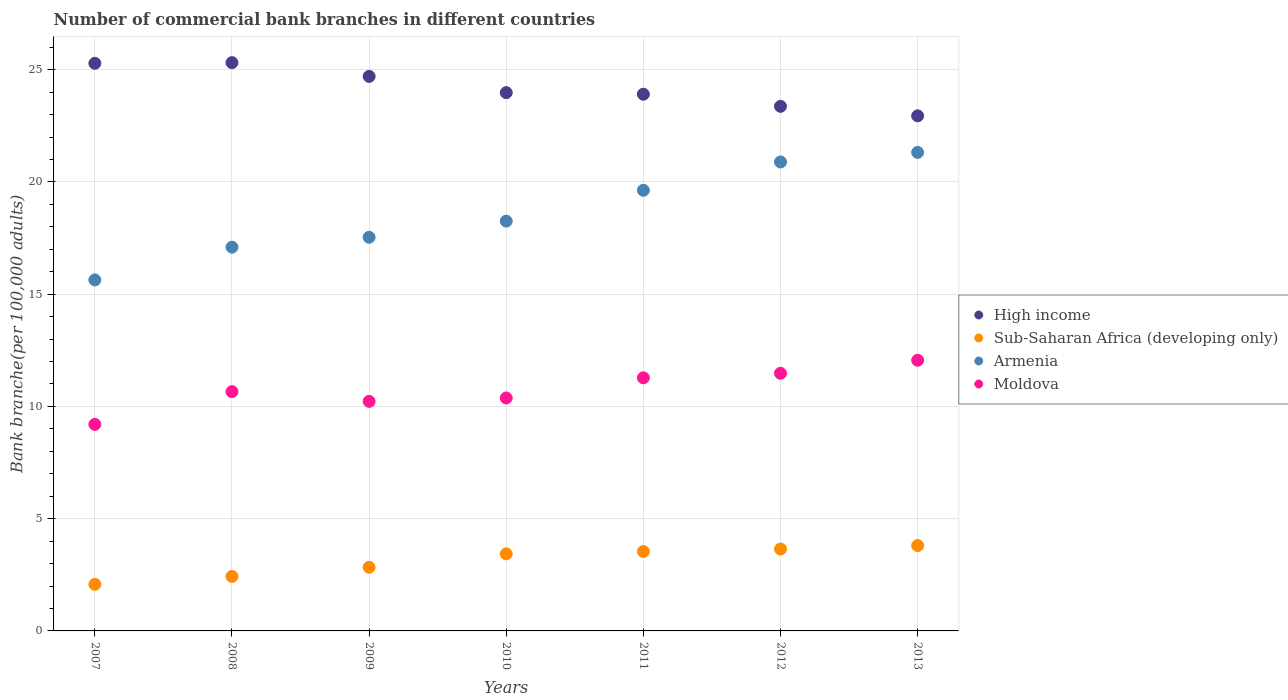How many different coloured dotlines are there?
Make the answer very short. 4. What is the number of commercial bank branches in Sub-Saharan Africa (developing only) in 2010?
Your answer should be compact. 3.43. Across all years, what is the maximum number of commercial bank branches in Moldova?
Keep it short and to the point. 12.06. Across all years, what is the minimum number of commercial bank branches in Sub-Saharan Africa (developing only)?
Your response must be concise. 2.07. In which year was the number of commercial bank branches in Sub-Saharan Africa (developing only) maximum?
Give a very brief answer. 2013. In which year was the number of commercial bank branches in Armenia minimum?
Your answer should be very brief. 2007. What is the total number of commercial bank branches in Armenia in the graph?
Your response must be concise. 130.35. What is the difference between the number of commercial bank branches in Sub-Saharan Africa (developing only) in 2009 and that in 2012?
Your answer should be very brief. -0.81. What is the difference between the number of commercial bank branches in Moldova in 2009 and the number of commercial bank branches in High income in 2008?
Your response must be concise. -15.09. What is the average number of commercial bank branches in Armenia per year?
Your answer should be very brief. 18.62. In the year 2010, what is the difference between the number of commercial bank branches in High income and number of commercial bank branches in Sub-Saharan Africa (developing only)?
Offer a terse response. 20.54. In how many years, is the number of commercial bank branches in High income greater than 4?
Your answer should be compact. 7. What is the ratio of the number of commercial bank branches in Moldova in 2009 to that in 2013?
Provide a short and direct response. 0.85. Is the difference between the number of commercial bank branches in High income in 2009 and 2013 greater than the difference between the number of commercial bank branches in Sub-Saharan Africa (developing only) in 2009 and 2013?
Your response must be concise. Yes. What is the difference between the highest and the second highest number of commercial bank branches in Armenia?
Your answer should be very brief. 0.43. What is the difference between the highest and the lowest number of commercial bank branches in Armenia?
Offer a terse response. 5.68. Is the sum of the number of commercial bank branches in High income in 2008 and 2012 greater than the maximum number of commercial bank branches in Sub-Saharan Africa (developing only) across all years?
Your answer should be compact. Yes. Is it the case that in every year, the sum of the number of commercial bank branches in High income and number of commercial bank branches in Armenia  is greater than the sum of number of commercial bank branches in Sub-Saharan Africa (developing only) and number of commercial bank branches in Moldova?
Give a very brief answer. Yes. Does the number of commercial bank branches in High income monotonically increase over the years?
Your response must be concise. No. Is the number of commercial bank branches in Moldova strictly greater than the number of commercial bank branches in Sub-Saharan Africa (developing only) over the years?
Ensure brevity in your answer.  Yes. Is the number of commercial bank branches in Armenia strictly less than the number of commercial bank branches in High income over the years?
Keep it short and to the point. Yes. What is the difference between two consecutive major ticks on the Y-axis?
Keep it short and to the point. 5. Are the values on the major ticks of Y-axis written in scientific E-notation?
Provide a short and direct response. No. Does the graph contain any zero values?
Your response must be concise. No. How are the legend labels stacked?
Keep it short and to the point. Vertical. What is the title of the graph?
Give a very brief answer. Number of commercial bank branches in different countries. What is the label or title of the X-axis?
Your answer should be compact. Years. What is the label or title of the Y-axis?
Provide a short and direct response. Bank branche(per 100,0 adults). What is the Bank branche(per 100,000 adults) of High income in 2007?
Your answer should be very brief. 25.28. What is the Bank branche(per 100,000 adults) in Sub-Saharan Africa (developing only) in 2007?
Your response must be concise. 2.07. What is the Bank branche(per 100,000 adults) of Armenia in 2007?
Your answer should be very brief. 15.63. What is the Bank branche(per 100,000 adults) in Moldova in 2007?
Your response must be concise. 9.2. What is the Bank branche(per 100,000 adults) in High income in 2008?
Your answer should be compact. 25.31. What is the Bank branche(per 100,000 adults) in Sub-Saharan Africa (developing only) in 2008?
Give a very brief answer. 2.43. What is the Bank branche(per 100,000 adults) of Armenia in 2008?
Your answer should be very brief. 17.09. What is the Bank branche(per 100,000 adults) of Moldova in 2008?
Provide a succinct answer. 10.66. What is the Bank branche(per 100,000 adults) of High income in 2009?
Provide a succinct answer. 24.7. What is the Bank branche(per 100,000 adults) in Sub-Saharan Africa (developing only) in 2009?
Provide a succinct answer. 2.83. What is the Bank branche(per 100,000 adults) of Armenia in 2009?
Ensure brevity in your answer.  17.53. What is the Bank branche(per 100,000 adults) of Moldova in 2009?
Keep it short and to the point. 10.23. What is the Bank branche(per 100,000 adults) in High income in 2010?
Provide a succinct answer. 23.98. What is the Bank branche(per 100,000 adults) in Sub-Saharan Africa (developing only) in 2010?
Provide a short and direct response. 3.43. What is the Bank branche(per 100,000 adults) in Armenia in 2010?
Keep it short and to the point. 18.25. What is the Bank branche(per 100,000 adults) in Moldova in 2010?
Offer a terse response. 10.38. What is the Bank branche(per 100,000 adults) in High income in 2011?
Your answer should be compact. 23.91. What is the Bank branche(per 100,000 adults) in Sub-Saharan Africa (developing only) in 2011?
Provide a succinct answer. 3.54. What is the Bank branche(per 100,000 adults) of Armenia in 2011?
Your response must be concise. 19.63. What is the Bank branche(per 100,000 adults) of Moldova in 2011?
Give a very brief answer. 11.28. What is the Bank branche(per 100,000 adults) of High income in 2012?
Offer a terse response. 23.37. What is the Bank branche(per 100,000 adults) of Sub-Saharan Africa (developing only) in 2012?
Ensure brevity in your answer.  3.65. What is the Bank branche(per 100,000 adults) in Armenia in 2012?
Provide a short and direct response. 20.89. What is the Bank branche(per 100,000 adults) in Moldova in 2012?
Keep it short and to the point. 11.48. What is the Bank branche(per 100,000 adults) of High income in 2013?
Your answer should be very brief. 22.94. What is the Bank branche(per 100,000 adults) in Sub-Saharan Africa (developing only) in 2013?
Offer a terse response. 3.8. What is the Bank branche(per 100,000 adults) in Armenia in 2013?
Keep it short and to the point. 21.32. What is the Bank branche(per 100,000 adults) of Moldova in 2013?
Your answer should be compact. 12.06. Across all years, what is the maximum Bank branche(per 100,000 adults) in High income?
Provide a short and direct response. 25.31. Across all years, what is the maximum Bank branche(per 100,000 adults) of Sub-Saharan Africa (developing only)?
Keep it short and to the point. 3.8. Across all years, what is the maximum Bank branche(per 100,000 adults) in Armenia?
Provide a short and direct response. 21.32. Across all years, what is the maximum Bank branche(per 100,000 adults) in Moldova?
Your response must be concise. 12.06. Across all years, what is the minimum Bank branche(per 100,000 adults) in High income?
Provide a succinct answer. 22.94. Across all years, what is the minimum Bank branche(per 100,000 adults) in Sub-Saharan Africa (developing only)?
Keep it short and to the point. 2.07. Across all years, what is the minimum Bank branche(per 100,000 adults) in Armenia?
Keep it short and to the point. 15.63. Across all years, what is the minimum Bank branche(per 100,000 adults) in Moldova?
Your response must be concise. 9.2. What is the total Bank branche(per 100,000 adults) in High income in the graph?
Provide a short and direct response. 169.49. What is the total Bank branche(per 100,000 adults) in Sub-Saharan Africa (developing only) in the graph?
Your response must be concise. 21.75. What is the total Bank branche(per 100,000 adults) in Armenia in the graph?
Your response must be concise. 130.35. What is the total Bank branche(per 100,000 adults) in Moldova in the graph?
Give a very brief answer. 75.27. What is the difference between the Bank branche(per 100,000 adults) in High income in 2007 and that in 2008?
Your response must be concise. -0.03. What is the difference between the Bank branche(per 100,000 adults) of Sub-Saharan Africa (developing only) in 2007 and that in 2008?
Your answer should be very brief. -0.35. What is the difference between the Bank branche(per 100,000 adults) of Armenia in 2007 and that in 2008?
Your answer should be very brief. -1.46. What is the difference between the Bank branche(per 100,000 adults) in Moldova in 2007 and that in 2008?
Make the answer very short. -1.46. What is the difference between the Bank branche(per 100,000 adults) of High income in 2007 and that in 2009?
Keep it short and to the point. 0.58. What is the difference between the Bank branche(per 100,000 adults) of Sub-Saharan Africa (developing only) in 2007 and that in 2009?
Ensure brevity in your answer.  -0.76. What is the difference between the Bank branche(per 100,000 adults) in Moldova in 2007 and that in 2009?
Provide a succinct answer. -1.02. What is the difference between the Bank branche(per 100,000 adults) in High income in 2007 and that in 2010?
Give a very brief answer. 1.31. What is the difference between the Bank branche(per 100,000 adults) in Sub-Saharan Africa (developing only) in 2007 and that in 2010?
Your answer should be very brief. -1.36. What is the difference between the Bank branche(per 100,000 adults) of Armenia in 2007 and that in 2010?
Your answer should be compact. -2.62. What is the difference between the Bank branche(per 100,000 adults) of Moldova in 2007 and that in 2010?
Offer a terse response. -1.18. What is the difference between the Bank branche(per 100,000 adults) in High income in 2007 and that in 2011?
Your answer should be very brief. 1.38. What is the difference between the Bank branche(per 100,000 adults) of Sub-Saharan Africa (developing only) in 2007 and that in 2011?
Offer a very short reply. -1.46. What is the difference between the Bank branche(per 100,000 adults) of Armenia in 2007 and that in 2011?
Offer a very short reply. -3.99. What is the difference between the Bank branche(per 100,000 adults) in Moldova in 2007 and that in 2011?
Offer a very short reply. -2.07. What is the difference between the Bank branche(per 100,000 adults) of High income in 2007 and that in 2012?
Your answer should be compact. 1.92. What is the difference between the Bank branche(per 100,000 adults) of Sub-Saharan Africa (developing only) in 2007 and that in 2012?
Provide a succinct answer. -1.57. What is the difference between the Bank branche(per 100,000 adults) of Armenia in 2007 and that in 2012?
Your answer should be very brief. -5.25. What is the difference between the Bank branche(per 100,000 adults) of Moldova in 2007 and that in 2012?
Keep it short and to the point. -2.27. What is the difference between the Bank branche(per 100,000 adults) in High income in 2007 and that in 2013?
Make the answer very short. 2.34. What is the difference between the Bank branche(per 100,000 adults) of Sub-Saharan Africa (developing only) in 2007 and that in 2013?
Keep it short and to the point. -1.73. What is the difference between the Bank branche(per 100,000 adults) in Armenia in 2007 and that in 2013?
Your answer should be compact. -5.68. What is the difference between the Bank branche(per 100,000 adults) in Moldova in 2007 and that in 2013?
Ensure brevity in your answer.  -2.86. What is the difference between the Bank branche(per 100,000 adults) in High income in 2008 and that in 2009?
Offer a very short reply. 0.61. What is the difference between the Bank branche(per 100,000 adults) in Sub-Saharan Africa (developing only) in 2008 and that in 2009?
Provide a short and direct response. -0.41. What is the difference between the Bank branche(per 100,000 adults) in Armenia in 2008 and that in 2009?
Offer a very short reply. -0.44. What is the difference between the Bank branche(per 100,000 adults) of Moldova in 2008 and that in 2009?
Provide a short and direct response. 0.43. What is the difference between the Bank branche(per 100,000 adults) in High income in 2008 and that in 2010?
Your answer should be compact. 1.34. What is the difference between the Bank branche(per 100,000 adults) in Sub-Saharan Africa (developing only) in 2008 and that in 2010?
Offer a very short reply. -1. What is the difference between the Bank branche(per 100,000 adults) of Armenia in 2008 and that in 2010?
Make the answer very short. -1.16. What is the difference between the Bank branche(per 100,000 adults) in Moldova in 2008 and that in 2010?
Your response must be concise. 0.28. What is the difference between the Bank branche(per 100,000 adults) of High income in 2008 and that in 2011?
Provide a short and direct response. 1.41. What is the difference between the Bank branche(per 100,000 adults) in Sub-Saharan Africa (developing only) in 2008 and that in 2011?
Offer a very short reply. -1.11. What is the difference between the Bank branche(per 100,000 adults) in Armenia in 2008 and that in 2011?
Give a very brief answer. -2.53. What is the difference between the Bank branche(per 100,000 adults) of Moldova in 2008 and that in 2011?
Your answer should be compact. -0.62. What is the difference between the Bank branche(per 100,000 adults) of High income in 2008 and that in 2012?
Your answer should be compact. 1.95. What is the difference between the Bank branche(per 100,000 adults) in Sub-Saharan Africa (developing only) in 2008 and that in 2012?
Your answer should be compact. -1.22. What is the difference between the Bank branche(per 100,000 adults) in Armenia in 2008 and that in 2012?
Your answer should be very brief. -3.79. What is the difference between the Bank branche(per 100,000 adults) in Moldova in 2008 and that in 2012?
Ensure brevity in your answer.  -0.82. What is the difference between the Bank branche(per 100,000 adults) in High income in 2008 and that in 2013?
Your response must be concise. 2.37. What is the difference between the Bank branche(per 100,000 adults) in Sub-Saharan Africa (developing only) in 2008 and that in 2013?
Ensure brevity in your answer.  -1.37. What is the difference between the Bank branche(per 100,000 adults) of Armenia in 2008 and that in 2013?
Provide a succinct answer. -4.22. What is the difference between the Bank branche(per 100,000 adults) in Moldova in 2008 and that in 2013?
Keep it short and to the point. -1.4. What is the difference between the Bank branche(per 100,000 adults) of High income in 2009 and that in 2010?
Offer a very short reply. 0.72. What is the difference between the Bank branche(per 100,000 adults) of Sub-Saharan Africa (developing only) in 2009 and that in 2010?
Your answer should be very brief. -0.6. What is the difference between the Bank branche(per 100,000 adults) of Armenia in 2009 and that in 2010?
Provide a succinct answer. -0.72. What is the difference between the Bank branche(per 100,000 adults) in Moldova in 2009 and that in 2010?
Your answer should be compact. -0.15. What is the difference between the Bank branche(per 100,000 adults) of High income in 2009 and that in 2011?
Your response must be concise. 0.79. What is the difference between the Bank branche(per 100,000 adults) of Sub-Saharan Africa (developing only) in 2009 and that in 2011?
Offer a terse response. -0.7. What is the difference between the Bank branche(per 100,000 adults) of Armenia in 2009 and that in 2011?
Keep it short and to the point. -2.09. What is the difference between the Bank branche(per 100,000 adults) in Moldova in 2009 and that in 2011?
Provide a succinct answer. -1.05. What is the difference between the Bank branche(per 100,000 adults) of High income in 2009 and that in 2012?
Your answer should be compact. 1.33. What is the difference between the Bank branche(per 100,000 adults) in Sub-Saharan Africa (developing only) in 2009 and that in 2012?
Keep it short and to the point. -0.81. What is the difference between the Bank branche(per 100,000 adults) of Armenia in 2009 and that in 2012?
Make the answer very short. -3.35. What is the difference between the Bank branche(per 100,000 adults) in Moldova in 2009 and that in 2012?
Provide a short and direct response. -1.25. What is the difference between the Bank branche(per 100,000 adults) in High income in 2009 and that in 2013?
Give a very brief answer. 1.76. What is the difference between the Bank branche(per 100,000 adults) of Sub-Saharan Africa (developing only) in 2009 and that in 2013?
Your answer should be very brief. -0.97. What is the difference between the Bank branche(per 100,000 adults) of Armenia in 2009 and that in 2013?
Give a very brief answer. -3.78. What is the difference between the Bank branche(per 100,000 adults) of Moldova in 2009 and that in 2013?
Keep it short and to the point. -1.83. What is the difference between the Bank branche(per 100,000 adults) of High income in 2010 and that in 2011?
Ensure brevity in your answer.  0.07. What is the difference between the Bank branche(per 100,000 adults) in Sub-Saharan Africa (developing only) in 2010 and that in 2011?
Offer a very short reply. -0.11. What is the difference between the Bank branche(per 100,000 adults) of Armenia in 2010 and that in 2011?
Offer a very short reply. -1.37. What is the difference between the Bank branche(per 100,000 adults) in Moldova in 2010 and that in 2011?
Your answer should be very brief. -0.9. What is the difference between the Bank branche(per 100,000 adults) of High income in 2010 and that in 2012?
Your answer should be very brief. 0.61. What is the difference between the Bank branche(per 100,000 adults) of Sub-Saharan Africa (developing only) in 2010 and that in 2012?
Your answer should be compact. -0.21. What is the difference between the Bank branche(per 100,000 adults) in Armenia in 2010 and that in 2012?
Offer a very short reply. -2.63. What is the difference between the Bank branche(per 100,000 adults) in Moldova in 2010 and that in 2012?
Offer a terse response. -1.1. What is the difference between the Bank branche(per 100,000 adults) in High income in 2010 and that in 2013?
Give a very brief answer. 1.03. What is the difference between the Bank branche(per 100,000 adults) in Sub-Saharan Africa (developing only) in 2010 and that in 2013?
Make the answer very short. -0.37. What is the difference between the Bank branche(per 100,000 adults) in Armenia in 2010 and that in 2013?
Your answer should be very brief. -3.06. What is the difference between the Bank branche(per 100,000 adults) of Moldova in 2010 and that in 2013?
Give a very brief answer. -1.68. What is the difference between the Bank branche(per 100,000 adults) of High income in 2011 and that in 2012?
Offer a very short reply. 0.54. What is the difference between the Bank branche(per 100,000 adults) of Sub-Saharan Africa (developing only) in 2011 and that in 2012?
Your response must be concise. -0.11. What is the difference between the Bank branche(per 100,000 adults) of Armenia in 2011 and that in 2012?
Your response must be concise. -1.26. What is the difference between the Bank branche(per 100,000 adults) of High income in 2011 and that in 2013?
Your answer should be compact. 0.96. What is the difference between the Bank branche(per 100,000 adults) in Sub-Saharan Africa (developing only) in 2011 and that in 2013?
Keep it short and to the point. -0.26. What is the difference between the Bank branche(per 100,000 adults) of Armenia in 2011 and that in 2013?
Offer a terse response. -1.69. What is the difference between the Bank branche(per 100,000 adults) of Moldova in 2011 and that in 2013?
Provide a succinct answer. -0.78. What is the difference between the Bank branche(per 100,000 adults) in High income in 2012 and that in 2013?
Make the answer very short. 0.42. What is the difference between the Bank branche(per 100,000 adults) of Sub-Saharan Africa (developing only) in 2012 and that in 2013?
Keep it short and to the point. -0.16. What is the difference between the Bank branche(per 100,000 adults) of Armenia in 2012 and that in 2013?
Your answer should be very brief. -0.43. What is the difference between the Bank branche(per 100,000 adults) of Moldova in 2012 and that in 2013?
Provide a succinct answer. -0.58. What is the difference between the Bank branche(per 100,000 adults) of High income in 2007 and the Bank branche(per 100,000 adults) of Sub-Saharan Africa (developing only) in 2008?
Give a very brief answer. 22.86. What is the difference between the Bank branche(per 100,000 adults) of High income in 2007 and the Bank branche(per 100,000 adults) of Armenia in 2008?
Make the answer very short. 8.19. What is the difference between the Bank branche(per 100,000 adults) in High income in 2007 and the Bank branche(per 100,000 adults) in Moldova in 2008?
Make the answer very short. 14.63. What is the difference between the Bank branche(per 100,000 adults) in Sub-Saharan Africa (developing only) in 2007 and the Bank branche(per 100,000 adults) in Armenia in 2008?
Your answer should be compact. -15.02. What is the difference between the Bank branche(per 100,000 adults) in Sub-Saharan Africa (developing only) in 2007 and the Bank branche(per 100,000 adults) in Moldova in 2008?
Give a very brief answer. -8.58. What is the difference between the Bank branche(per 100,000 adults) of Armenia in 2007 and the Bank branche(per 100,000 adults) of Moldova in 2008?
Your answer should be compact. 4.98. What is the difference between the Bank branche(per 100,000 adults) in High income in 2007 and the Bank branche(per 100,000 adults) in Sub-Saharan Africa (developing only) in 2009?
Offer a very short reply. 22.45. What is the difference between the Bank branche(per 100,000 adults) of High income in 2007 and the Bank branche(per 100,000 adults) of Armenia in 2009?
Make the answer very short. 7.75. What is the difference between the Bank branche(per 100,000 adults) in High income in 2007 and the Bank branche(per 100,000 adults) in Moldova in 2009?
Ensure brevity in your answer.  15.06. What is the difference between the Bank branche(per 100,000 adults) of Sub-Saharan Africa (developing only) in 2007 and the Bank branche(per 100,000 adults) of Armenia in 2009?
Your answer should be very brief. -15.46. What is the difference between the Bank branche(per 100,000 adults) of Sub-Saharan Africa (developing only) in 2007 and the Bank branche(per 100,000 adults) of Moldova in 2009?
Ensure brevity in your answer.  -8.15. What is the difference between the Bank branche(per 100,000 adults) in Armenia in 2007 and the Bank branche(per 100,000 adults) in Moldova in 2009?
Ensure brevity in your answer.  5.41. What is the difference between the Bank branche(per 100,000 adults) of High income in 2007 and the Bank branche(per 100,000 adults) of Sub-Saharan Africa (developing only) in 2010?
Your answer should be very brief. 21.85. What is the difference between the Bank branche(per 100,000 adults) in High income in 2007 and the Bank branche(per 100,000 adults) in Armenia in 2010?
Your response must be concise. 7.03. What is the difference between the Bank branche(per 100,000 adults) in High income in 2007 and the Bank branche(per 100,000 adults) in Moldova in 2010?
Provide a short and direct response. 14.91. What is the difference between the Bank branche(per 100,000 adults) in Sub-Saharan Africa (developing only) in 2007 and the Bank branche(per 100,000 adults) in Armenia in 2010?
Make the answer very short. -16.18. What is the difference between the Bank branche(per 100,000 adults) of Sub-Saharan Africa (developing only) in 2007 and the Bank branche(per 100,000 adults) of Moldova in 2010?
Offer a very short reply. -8.3. What is the difference between the Bank branche(per 100,000 adults) of Armenia in 2007 and the Bank branche(per 100,000 adults) of Moldova in 2010?
Provide a short and direct response. 5.26. What is the difference between the Bank branche(per 100,000 adults) in High income in 2007 and the Bank branche(per 100,000 adults) in Sub-Saharan Africa (developing only) in 2011?
Provide a succinct answer. 21.75. What is the difference between the Bank branche(per 100,000 adults) of High income in 2007 and the Bank branche(per 100,000 adults) of Armenia in 2011?
Make the answer very short. 5.66. What is the difference between the Bank branche(per 100,000 adults) in High income in 2007 and the Bank branche(per 100,000 adults) in Moldova in 2011?
Your answer should be very brief. 14.01. What is the difference between the Bank branche(per 100,000 adults) in Sub-Saharan Africa (developing only) in 2007 and the Bank branche(per 100,000 adults) in Armenia in 2011?
Provide a succinct answer. -17.55. What is the difference between the Bank branche(per 100,000 adults) in Sub-Saharan Africa (developing only) in 2007 and the Bank branche(per 100,000 adults) in Moldova in 2011?
Your response must be concise. -9.2. What is the difference between the Bank branche(per 100,000 adults) in Armenia in 2007 and the Bank branche(per 100,000 adults) in Moldova in 2011?
Provide a short and direct response. 4.36. What is the difference between the Bank branche(per 100,000 adults) of High income in 2007 and the Bank branche(per 100,000 adults) of Sub-Saharan Africa (developing only) in 2012?
Provide a short and direct response. 21.64. What is the difference between the Bank branche(per 100,000 adults) in High income in 2007 and the Bank branche(per 100,000 adults) in Armenia in 2012?
Give a very brief answer. 4.4. What is the difference between the Bank branche(per 100,000 adults) of High income in 2007 and the Bank branche(per 100,000 adults) of Moldova in 2012?
Offer a terse response. 13.81. What is the difference between the Bank branche(per 100,000 adults) in Sub-Saharan Africa (developing only) in 2007 and the Bank branche(per 100,000 adults) in Armenia in 2012?
Offer a very short reply. -18.81. What is the difference between the Bank branche(per 100,000 adults) of Sub-Saharan Africa (developing only) in 2007 and the Bank branche(per 100,000 adults) of Moldova in 2012?
Keep it short and to the point. -9.4. What is the difference between the Bank branche(per 100,000 adults) in Armenia in 2007 and the Bank branche(per 100,000 adults) in Moldova in 2012?
Your response must be concise. 4.16. What is the difference between the Bank branche(per 100,000 adults) of High income in 2007 and the Bank branche(per 100,000 adults) of Sub-Saharan Africa (developing only) in 2013?
Your answer should be compact. 21.48. What is the difference between the Bank branche(per 100,000 adults) of High income in 2007 and the Bank branche(per 100,000 adults) of Armenia in 2013?
Keep it short and to the point. 3.97. What is the difference between the Bank branche(per 100,000 adults) in High income in 2007 and the Bank branche(per 100,000 adults) in Moldova in 2013?
Offer a very short reply. 13.23. What is the difference between the Bank branche(per 100,000 adults) in Sub-Saharan Africa (developing only) in 2007 and the Bank branche(per 100,000 adults) in Armenia in 2013?
Provide a succinct answer. -19.24. What is the difference between the Bank branche(per 100,000 adults) of Sub-Saharan Africa (developing only) in 2007 and the Bank branche(per 100,000 adults) of Moldova in 2013?
Give a very brief answer. -9.98. What is the difference between the Bank branche(per 100,000 adults) of Armenia in 2007 and the Bank branche(per 100,000 adults) of Moldova in 2013?
Ensure brevity in your answer.  3.58. What is the difference between the Bank branche(per 100,000 adults) of High income in 2008 and the Bank branche(per 100,000 adults) of Sub-Saharan Africa (developing only) in 2009?
Keep it short and to the point. 22.48. What is the difference between the Bank branche(per 100,000 adults) of High income in 2008 and the Bank branche(per 100,000 adults) of Armenia in 2009?
Provide a short and direct response. 7.78. What is the difference between the Bank branche(per 100,000 adults) of High income in 2008 and the Bank branche(per 100,000 adults) of Moldova in 2009?
Ensure brevity in your answer.  15.09. What is the difference between the Bank branche(per 100,000 adults) in Sub-Saharan Africa (developing only) in 2008 and the Bank branche(per 100,000 adults) in Armenia in 2009?
Offer a terse response. -15.11. What is the difference between the Bank branche(per 100,000 adults) in Sub-Saharan Africa (developing only) in 2008 and the Bank branche(per 100,000 adults) in Moldova in 2009?
Offer a very short reply. -7.8. What is the difference between the Bank branche(per 100,000 adults) of Armenia in 2008 and the Bank branche(per 100,000 adults) of Moldova in 2009?
Keep it short and to the point. 6.87. What is the difference between the Bank branche(per 100,000 adults) in High income in 2008 and the Bank branche(per 100,000 adults) in Sub-Saharan Africa (developing only) in 2010?
Offer a terse response. 21.88. What is the difference between the Bank branche(per 100,000 adults) in High income in 2008 and the Bank branche(per 100,000 adults) in Armenia in 2010?
Your answer should be very brief. 7.06. What is the difference between the Bank branche(per 100,000 adults) of High income in 2008 and the Bank branche(per 100,000 adults) of Moldova in 2010?
Provide a short and direct response. 14.94. What is the difference between the Bank branche(per 100,000 adults) of Sub-Saharan Africa (developing only) in 2008 and the Bank branche(per 100,000 adults) of Armenia in 2010?
Ensure brevity in your answer.  -15.83. What is the difference between the Bank branche(per 100,000 adults) of Sub-Saharan Africa (developing only) in 2008 and the Bank branche(per 100,000 adults) of Moldova in 2010?
Your response must be concise. -7.95. What is the difference between the Bank branche(per 100,000 adults) in Armenia in 2008 and the Bank branche(per 100,000 adults) in Moldova in 2010?
Your answer should be very brief. 6.72. What is the difference between the Bank branche(per 100,000 adults) in High income in 2008 and the Bank branche(per 100,000 adults) in Sub-Saharan Africa (developing only) in 2011?
Your response must be concise. 21.77. What is the difference between the Bank branche(per 100,000 adults) of High income in 2008 and the Bank branche(per 100,000 adults) of Armenia in 2011?
Provide a short and direct response. 5.69. What is the difference between the Bank branche(per 100,000 adults) of High income in 2008 and the Bank branche(per 100,000 adults) of Moldova in 2011?
Offer a very short reply. 14.04. What is the difference between the Bank branche(per 100,000 adults) in Sub-Saharan Africa (developing only) in 2008 and the Bank branche(per 100,000 adults) in Armenia in 2011?
Provide a short and direct response. -17.2. What is the difference between the Bank branche(per 100,000 adults) of Sub-Saharan Africa (developing only) in 2008 and the Bank branche(per 100,000 adults) of Moldova in 2011?
Make the answer very short. -8.85. What is the difference between the Bank branche(per 100,000 adults) of Armenia in 2008 and the Bank branche(per 100,000 adults) of Moldova in 2011?
Offer a terse response. 5.82. What is the difference between the Bank branche(per 100,000 adults) in High income in 2008 and the Bank branche(per 100,000 adults) in Sub-Saharan Africa (developing only) in 2012?
Keep it short and to the point. 21.67. What is the difference between the Bank branche(per 100,000 adults) in High income in 2008 and the Bank branche(per 100,000 adults) in Armenia in 2012?
Make the answer very short. 4.42. What is the difference between the Bank branche(per 100,000 adults) in High income in 2008 and the Bank branche(per 100,000 adults) in Moldova in 2012?
Provide a short and direct response. 13.84. What is the difference between the Bank branche(per 100,000 adults) in Sub-Saharan Africa (developing only) in 2008 and the Bank branche(per 100,000 adults) in Armenia in 2012?
Provide a succinct answer. -18.46. What is the difference between the Bank branche(per 100,000 adults) in Sub-Saharan Africa (developing only) in 2008 and the Bank branche(per 100,000 adults) in Moldova in 2012?
Provide a succinct answer. -9.05. What is the difference between the Bank branche(per 100,000 adults) of Armenia in 2008 and the Bank branche(per 100,000 adults) of Moldova in 2012?
Your answer should be compact. 5.62. What is the difference between the Bank branche(per 100,000 adults) of High income in 2008 and the Bank branche(per 100,000 adults) of Sub-Saharan Africa (developing only) in 2013?
Provide a succinct answer. 21.51. What is the difference between the Bank branche(per 100,000 adults) of High income in 2008 and the Bank branche(per 100,000 adults) of Armenia in 2013?
Keep it short and to the point. 4. What is the difference between the Bank branche(per 100,000 adults) of High income in 2008 and the Bank branche(per 100,000 adults) of Moldova in 2013?
Provide a succinct answer. 13.26. What is the difference between the Bank branche(per 100,000 adults) in Sub-Saharan Africa (developing only) in 2008 and the Bank branche(per 100,000 adults) in Armenia in 2013?
Provide a succinct answer. -18.89. What is the difference between the Bank branche(per 100,000 adults) of Sub-Saharan Africa (developing only) in 2008 and the Bank branche(per 100,000 adults) of Moldova in 2013?
Offer a very short reply. -9.63. What is the difference between the Bank branche(per 100,000 adults) of Armenia in 2008 and the Bank branche(per 100,000 adults) of Moldova in 2013?
Your answer should be compact. 5.04. What is the difference between the Bank branche(per 100,000 adults) in High income in 2009 and the Bank branche(per 100,000 adults) in Sub-Saharan Africa (developing only) in 2010?
Ensure brevity in your answer.  21.27. What is the difference between the Bank branche(per 100,000 adults) in High income in 2009 and the Bank branche(per 100,000 adults) in Armenia in 2010?
Keep it short and to the point. 6.45. What is the difference between the Bank branche(per 100,000 adults) in High income in 2009 and the Bank branche(per 100,000 adults) in Moldova in 2010?
Keep it short and to the point. 14.32. What is the difference between the Bank branche(per 100,000 adults) in Sub-Saharan Africa (developing only) in 2009 and the Bank branche(per 100,000 adults) in Armenia in 2010?
Ensure brevity in your answer.  -15.42. What is the difference between the Bank branche(per 100,000 adults) in Sub-Saharan Africa (developing only) in 2009 and the Bank branche(per 100,000 adults) in Moldova in 2010?
Keep it short and to the point. -7.54. What is the difference between the Bank branche(per 100,000 adults) in Armenia in 2009 and the Bank branche(per 100,000 adults) in Moldova in 2010?
Offer a very short reply. 7.16. What is the difference between the Bank branche(per 100,000 adults) in High income in 2009 and the Bank branche(per 100,000 adults) in Sub-Saharan Africa (developing only) in 2011?
Make the answer very short. 21.16. What is the difference between the Bank branche(per 100,000 adults) of High income in 2009 and the Bank branche(per 100,000 adults) of Armenia in 2011?
Offer a terse response. 5.07. What is the difference between the Bank branche(per 100,000 adults) of High income in 2009 and the Bank branche(per 100,000 adults) of Moldova in 2011?
Provide a short and direct response. 13.42. What is the difference between the Bank branche(per 100,000 adults) of Sub-Saharan Africa (developing only) in 2009 and the Bank branche(per 100,000 adults) of Armenia in 2011?
Provide a succinct answer. -16.79. What is the difference between the Bank branche(per 100,000 adults) of Sub-Saharan Africa (developing only) in 2009 and the Bank branche(per 100,000 adults) of Moldova in 2011?
Your answer should be very brief. -8.44. What is the difference between the Bank branche(per 100,000 adults) of Armenia in 2009 and the Bank branche(per 100,000 adults) of Moldova in 2011?
Your response must be concise. 6.26. What is the difference between the Bank branche(per 100,000 adults) of High income in 2009 and the Bank branche(per 100,000 adults) of Sub-Saharan Africa (developing only) in 2012?
Give a very brief answer. 21.05. What is the difference between the Bank branche(per 100,000 adults) of High income in 2009 and the Bank branche(per 100,000 adults) of Armenia in 2012?
Offer a very short reply. 3.81. What is the difference between the Bank branche(per 100,000 adults) of High income in 2009 and the Bank branche(per 100,000 adults) of Moldova in 2012?
Offer a terse response. 13.22. What is the difference between the Bank branche(per 100,000 adults) of Sub-Saharan Africa (developing only) in 2009 and the Bank branche(per 100,000 adults) of Armenia in 2012?
Offer a terse response. -18.05. What is the difference between the Bank branche(per 100,000 adults) in Sub-Saharan Africa (developing only) in 2009 and the Bank branche(per 100,000 adults) in Moldova in 2012?
Provide a succinct answer. -8.64. What is the difference between the Bank branche(per 100,000 adults) in Armenia in 2009 and the Bank branche(per 100,000 adults) in Moldova in 2012?
Your answer should be compact. 6.06. What is the difference between the Bank branche(per 100,000 adults) in High income in 2009 and the Bank branche(per 100,000 adults) in Sub-Saharan Africa (developing only) in 2013?
Offer a terse response. 20.9. What is the difference between the Bank branche(per 100,000 adults) in High income in 2009 and the Bank branche(per 100,000 adults) in Armenia in 2013?
Keep it short and to the point. 3.38. What is the difference between the Bank branche(per 100,000 adults) in High income in 2009 and the Bank branche(per 100,000 adults) in Moldova in 2013?
Provide a short and direct response. 12.64. What is the difference between the Bank branche(per 100,000 adults) in Sub-Saharan Africa (developing only) in 2009 and the Bank branche(per 100,000 adults) in Armenia in 2013?
Give a very brief answer. -18.48. What is the difference between the Bank branche(per 100,000 adults) in Sub-Saharan Africa (developing only) in 2009 and the Bank branche(per 100,000 adults) in Moldova in 2013?
Your answer should be compact. -9.22. What is the difference between the Bank branche(per 100,000 adults) of Armenia in 2009 and the Bank branche(per 100,000 adults) of Moldova in 2013?
Make the answer very short. 5.48. What is the difference between the Bank branche(per 100,000 adults) of High income in 2010 and the Bank branche(per 100,000 adults) of Sub-Saharan Africa (developing only) in 2011?
Offer a very short reply. 20.44. What is the difference between the Bank branche(per 100,000 adults) of High income in 2010 and the Bank branche(per 100,000 adults) of Armenia in 2011?
Make the answer very short. 4.35. What is the difference between the Bank branche(per 100,000 adults) of High income in 2010 and the Bank branche(per 100,000 adults) of Moldova in 2011?
Offer a very short reply. 12.7. What is the difference between the Bank branche(per 100,000 adults) in Sub-Saharan Africa (developing only) in 2010 and the Bank branche(per 100,000 adults) in Armenia in 2011?
Provide a short and direct response. -16.19. What is the difference between the Bank branche(per 100,000 adults) of Sub-Saharan Africa (developing only) in 2010 and the Bank branche(per 100,000 adults) of Moldova in 2011?
Provide a succinct answer. -7.84. What is the difference between the Bank branche(per 100,000 adults) of Armenia in 2010 and the Bank branche(per 100,000 adults) of Moldova in 2011?
Offer a terse response. 6.98. What is the difference between the Bank branche(per 100,000 adults) of High income in 2010 and the Bank branche(per 100,000 adults) of Sub-Saharan Africa (developing only) in 2012?
Ensure brevity in your answer.  20.33. What is the difference between the Bank branche(per 100,000 adults) in High income in 2010 and the Bank branche(per 100,000 adults) in Armenia in 2012?
Your answer should be compact. 3.09. What is the difference between the Bank branche(per 100,000 adults) of High income in 2010 and the Bank branche(per 100,000 adults) of Moldova in 2012?
Provide a short and direct response. 12.5. What is the difference between the Bank branche(per 100,000 adults) in Sub-Saharan Africa (developing only) in 2010 and the Bank branche(per 100,000 adults) in Armenia in 2012?
Provide a short and direct response. -17.46. What is the difference between the Bank branche(per 100,000 adults) of Sub-Saharan Africa (developing only) in 2010 and the Bank branche(per 100,000 adults) of Moldova in 2012?
Your response must be concise. -8.04. What is the difference between the Bank branche(per 100,000 adults) of Armenia in 2010 and the Bank branche(per 100,000 adults) of Moldova in 2012?
Give a very brief answer. 6.78. What is the difference between the Bank branche(per 100,000 adults) of High income in 2010 and the Bank branche(per 100,000 adults) of Sub-Saharan Africa (developing only) in 2013?
Your response must be concise. 20.17. What is the difference between the Bank branche(per 100,000 adults) of High income in 2010 and the Bank branche(per 100,000 adults) of Armenia in 2013?
Your response must be concise. 2.66. What is the difference between the Bank branche(per 100,000 adults) of High income in 2010 and the Bank branche(per 100,000 adults) of Moldova in 2013?
Make the answer very short. 11.92. What is the difference between the Bank branche(per 100,000 adults) in Sub-Saharan Africa (developing only) in 2010 and the Bank branche(per 100,000 adults) in Armenia in 2013?
Provide a short and direct response. -17.88. What is the difference between the Bank branche(per 100,000 adults) of Sub-Saharan Africa (developing only) in 2010 and the Bank branche(per 100,000 adults) of Moldova in 2013?
Your answer should be very brief. -8.62. What is the difference between the Bank branche(per 100,000 adults) of Armenia in 2010 and the Bank branche(per 100,000 adults) of Moldova in 2013?
Make the answer very short. 6.2. What is the difference between the Bank branche(per 100,000 adults) in High income in 2011 and the Bank branche(per 100,000 adults) in Sub-Saharan Africa (developing only) in 2012?
Offer a very short reply. 20.26. What is the difference between the Bank branche(per 100,000 adults) of High income in 2011 and the Bank branche(per 100,000 adults) of Armenia in 2012?
Ensure brevity in your answer.  3.02. What is the difference between the Bank branche(per 100,000 adults) of High income in 2011 and the Bank branche(per 100,000 adults) of Moldova in 2012?
Provide a succinct answer. 12.43. What is the difference between the Bank branche(per 100,000 adults) of Sub-Saharan Africa (developing only) in 2011 and the Bank branche(per 100,000 adults) of Armenia in 2012?
Offer a very short reply. -17.35. What is the difference between the Bank branche(per 100,000 adults) of Sub-Saharan Africa (developing only) in 2011 and the Bank branche(per 100,000 adults) of Moldova in 2012?
Make the answer very short. -7.94. What is the difference between the Bank branche(per 100,000 adults) of Armenia in 2011 and the Bank branche(per 100,000 adults) of Moldova in 2012?
Ensure brevity in your answer.  8.15. What is the difference between the Bank branche(per 100,000 adults) of High income in 2011 and the Bank branche(per 100,000 adults) of Sub-Saharan Africa (developing only) in 2013?
Keep it short and to the point. 20.1. What is the difference between the Bank branche(per 100,000 adults) in High income in 2011 and the Bank branche(per 100,000 adults) in Armenia in 2013?
Give a very brief answer. 2.59. What is the difference between the Bank branche(per 100,000 adults) in High income in 2011 and the Bank branche(per 100,000 adults) in Moldova in 2013?
Your response must be concise. 11.85. What is the difference between the Bank branche(per 100,000 adults) of Sub-Saharan Africa (developing only) in 2011 and the Bank branche(per 100,000 adults) of Armenia in 2013?
Ensure brevity in your answer.  -17.78. What is the difference between the Bank branche(per 100,000 adults) in Sub-Saharan Africa (developing only) in 2011 and the Bank branche(per 100,000 adults) in Moldova in 2013?
Make the answer very short. -8.52. What is the difference between the Bank branche(per 100,000 adults) in Armenia in 2011 and the Bank branche(per 100,000 adults) in Moldova in 2013?
Your answer should be very brief. 7.57. What is the difference between the Bank branche(per 100,000 adults) in High income in 2012 and the Bank branche(per 100,000 adults) in Sub-Saharan Africa (developing only) in 2013?
Provide a succinct answer. 19.56. What is the difference between the Bank branche(per 100,000 adults) in High income in 2012 and the Bank branche(per 100,000 adults) in Armenia in 2013?
Make the answer very short. 2.05. What is the difference between the Bank branche(per 100,000 adults) in High income in 2012 and the Bank branche(per 100,000 adults) in Moldova in 2013?
Give a very brief answer. 11.31. What is the difference between the Bank branche(per 100,000 adults) in Sub-Saharan Africa (developing only) in 2012 and the Bank branche(per 100,000 adults) in Armenia in 2013?
Ensure brevity in your answer.  -17.67. What is the difference between the Bank branche(per 100,000 adults) in Sub-Saharan Africa (developing only) in 2012 and the Bank branche(per 100,000 adults) in Moldova in 2013?
Give a very brief answer. -8.41. What is the difference between the Bank branche(per 100,000 adults) in Armenia in 2012 and the Bank branche(per 100,000 adults) in Moldova in 2013?
Your response must be concise. 8.83. What is the average Bank branche(per 100,000 adults) in High income per year?
Provide a short and direct response. 24.21. What is the average Bank branche(per 100,000 adults) in Sub-Saharan Africa (developing only) per year?
Give a very brief answer. 3.11. What is the average Bank branche(per 100,000 adults) in Armenia per year?
Keep it short and to the point. 18.62. What is the average Bank branche(per 100,000 adults) of Moldova per year?
Make the answer very short. 10.75. In the year 2007, what is the difference between the Bank branche(per 100,000 adults) of High income and Bank branche(per 100,000 adults) of Sub-Saharan Africa (developing only)?
Offer a very short reply. 23.21. In the year 2007, what is the difference between the Bank branche(per 100,000 adults) of High income and Bank branche(per 100,000 adults) of Armenia?
Give a very brief answer. 9.65. In the year 2007, what is the difference between the Bank branche(per 100,000 adults) in High income and Bank branche(per 100,000 adults) in Moldova?
Your response must be concise. 16.08. In the year 2007, what is the difference between the Bank branche(per 100,000 adults) of Sub-Saharan Africa (developing only) and Bank branche(per 100,000 adults) of Armenia?
Your answer should be compact. -13.56. In the year 2007, what is the difference between the Bank branche(per 100,000 adults) in Sub-Saharan Africa (developing only) and Bank branche(per 100,000 adults) in Moldova?
Your answer should be compact. -7.13. In the year 2007, what is the difference between the Bank branche(per 100,000 adults) in Armenia and Bank branche(per 100,000 adults) in Moldova?
Your answer should be compact. 6.43. In the year 2008, what is the difference between the Bank branche(per 100,000 adults) in High income and Bank branche(per 100,000 adults) in Sub-Saharan Africa (developing only)?
Provide a short and direct response. 22.88. In the year 2008, what is the difference between the Bank branche(per 100,000 adults) in High income and Bank branche(per 100,000 adults) in Armenia?
Provide a short and direct response. 8.22. In the year 2008, what is the difference between the Bank branche(per 100,000 adults) in High income and Bank branche(per 100,000 adults) in Moldova?
Provide a short and direct response. 14.65. In the year 2008, what is the difference between the Bank branche(per 100,000 adults) of Sub-Saharan Africa (developing only) and Bank branche(per 100,000 adults) of Armenia?
Keep it short and to the point. -14.67. In the year 2008, what is the difference between the Bank branche(per 100,000 adults) of Sub-Saharan Africa (developing only) and Bank branche(per 100,000 adults) of Moldova?
Offer a very short reply. -8.23. In the year 2008, what is the difference between the Bank branche(per 100,000 adults) of Armenia and Bank branche(per 100,000 adults) of Moldova?
Provide a short and direct response. 6.44. In the year 2009, what is the difference between the Bank branche(per 100,000 adults) of High income and Bank branche(per 100,000 adults) of Sub-Saharan Africa (developing only)?
Your response must be concise. 21.87. In the year 2009, what is the difference between the Bank branche(per 100,000 adults) of High income and Bank branche(per 100,000 adults) of Armenia?
Provide a succinct answer. 7.17. In the year 2009, what is the difference between the Bank branche(per 100,000 adults) in High income and Bank branche(per 100,000 adults) in Moldova?
Ensure brevity in your answer.  14.48. In the year 2009, what is the difference between the Bank branche(per 100,000 adults) in Sub-Saharan Africa (developing only) and Bank branche(per 100,000 adults) in Armenia?
Provide a short and direct response. -14.7. In the year 2009, what is the difference between the Bank branche(per 100,000 adults) of Sub-Saharan Africa (developing only) and Bank branche(per 100,000 adults) of Moldova?
Give a very brief answer. -7.39. In the year 2009, what is the difference between the Bank branche(per 100,000 adults) of Armenia and Bank branche(per 100,000 adults) of Moldova?
Ensure brevity in your answer.  7.31. In the year 2010, what is the difference between the Bank branche(per 100,000 adults) in High income and Bank branche(per 100,000 adults) in Sub-Saharan Africa (developing only)?
Your answer should be compact. 20.54. In the year 2010, what is the difference between the Bank branche(per 100,000 adults) of High income and Bank branche(per 100,000 adults) of Armenia?
Keep it short and to the point. 5.72. In the year 2010, what is the difference between the Bank branche(per 100,000 adults) in High income and Bank branche(per 100,000 adults) in Moldova?
Make the answer very short. 13.6. In the year 2010, what is the difference between the Bank branche(per 100,000 adults) in Sub-Saharan Africa (developing only) and Bank branche(per 100,000 adults) in Armenia?
Ensure brevity in your answer.  -14.82. In the year 2010, what is the difference between the Bank branche(per 100,000 adults) in Sub-Saharan Africa (developing only) and Bank branche(per 100,000 adults) in Moldova?
Offer a very short reply. -6.94. In the year 2010, what is the difference between the Bank branche(per 100,000 adults) of Armenia and Bank branche(per 100,000 adults) of Moldova?
Make the answer very short. 7.88. In the year 2011, what is the difference between the Bank branche(per 100,000 adults) of High income and Bank branche(per 100,000 adults) of Sub-Saharan Africa (developing only)?
Make the answer very short. 20.37. In the year 2011, what is the difference between the Bank branche(per 100,000 adults) in High income and Bank branche(per 100,000 adults) in Armenia?
Your answer should be compact. 4.28. In the year 2011, what is the difference between the Bank branche(per 100,000 adults) in High income and Bank branche(per 100,000 adults) in Moldova?
Your response must be concise. 12.63. In the year 2011, what is the difference between the Bank branche(per 100,000 adults) in Sub-Saharan Africa (developing only) and Bank branche(per 100,000 adults) in Armenia?
Keep it short and to the point. -16.09. In the year 2011, what is the difference between the Bank branche(per 100,000 adults) of Sub-Saharan Africa (developing only) and Bank branche(per 100,000 adults) of Moldova?
Make the answer very short. -7.74. In the year 2011, what is the difference between the Bank branche(per 100,000 adults) in Armenia and Bank branche(per 100,000 adults) in Moldova?
Your answer should be compact. 8.35. In the year 2012, what is the difference between the Bank branche(per 100,000 adults) of High income and Bank branche(per 100,000 adults) of Sub-Saharan Africa (developing only)?
Give a very brief answer. 19.72. In the year 2012, what is the difference between the Bank branche(per 100,000 adults) of High income and Bank branche(per 100,000 adults) of Armenia?
Give a very brief answer. 2.48. In the year 2012, what is the difference between the Bank branche(per 100,000 adults) in High income and Bank branche(per 100,000 adults) in Moldova?
Ensure brevity in your answer.  11.89. In the year 2012, what is the difference between the Bank branche(per 100,000 adults) in Sub-Saharan Africa (developing only) and Bank branche(per 100,000 adults) in Armenia?
Your answer should be very brief. -17.24. In the year 2012, what is the difference between the Bank branche(per 100,000 adults) of Sub-Saharan Africa (developing only) and Bank branche(per 100,000 adults) of Moldova?
Your answer should be very brief. -7.83. In the year 2012, what is the difference between the Bank branche(per 100,000 adults) of Armenia and Bank branche(per 100,000 adults) of Moldova?
Offer a terse response. 9.41. In the year 2013, what is the difference between the Bank branche(per 100,000 adults) of High income and Bank branche(per 100,000 adults) of Sub-Saharan Africa (developing only)?
Keep it short and to the point. 19.14. In the year 2013, what is the difference between the Bank branche(per 100,000 adults) in High income and Bank branche(per 100,000 adults) in Armenia?
Keep it short and to the point. 1.63. In the year 2013, what is the difference between the Bank branche(per 100,000 adults) in High income and Bank branche(per 100,000 adults) in Moldova?
Your answer should be very brief. 10.89. In the year 2013, what is the difference between the Bank branche(per 100,000 adults) of Sub-Saharan Africa (developing only) and Bank branche(per 100,000 adults) of Armenia?
Make the answer very short. -17.51. In the year 2013, what is the difference between the Bank branche(per 100,000 adults) of Sub-Saharan Africa (developing only) and Bank branche(per 100,000 adults) of Moldova?
Offer a very short reply. -8.25. In the year 2013, what is the difference between the Bank branche(per 100,000 adults) in Armenia and Bank branche(per 100,000 adults) in Moldova?
Your answer should be very brief. 9.26. What is the ratio of the Bank branche(per 100,000 adults) of High income in 2007 to that in 2008?
Ensure brevity in your answer.  1. What is the ratio of the Bank branche(per 100,000 adults) of Sub-Saharan Africa (developing only) in 2007 to that in 2008?
Your answer should be very brief. 0.85. What is the ratio of the Bank branche(per 100,000 adults) in Armenia in 2007 to that in 2008?
Offer a terse response. 0.91. What is the ratio of the Bank branche(per 100,000 adults) of Moldova in 2007 to that in 2008?
Keep it short and to the point. 0.86. What is the ratio of the Bank branche(per 100,000 adults) in High income in 2007 to that in 2009?
Your answer should be compact. 1.02. What is the ratio of the Bank branche(per 100,000 adults) of Sub-Saharan Africa (developing only) in 2007 to that in 2009?
Make the answer very short. 0.73. What is the ratio of the Bank branche(per 100,000 adults) in Armenia in 2007 to that in 2009?
Your answer should be very brief. 0.89. What is the ratio of the Bank branche(per 100,000 adults) in Moldova in 2007 to that in 2009?
Provide a short and direct response. 0.9. What is the ratio of the Bank branche(per 100,000 adults) in High income in 2007 to that in 2010?
Your answer should be very brief. 1.05. What is the ratio of the Bank branche(per 100,000 adults) of Sub-Saharan Africa (developing only) in 2007 to that in 2010?
Make the answer very short. 0.6. What is the ratio of the Bank branche(per 100,000 adults) of Armenia in 2007 to that in 2010?
Make the answer very short. 0.86. What is the ratio of the Bank branche(per 100,000 adults) of Moldova in 2007 to that in 2010?
Offer a very short reply. 0.89. What is the ratio of the Bank branche(per 100,000 adults) of High income in 2007 to that in 2011?
Ensure brevity in your answer.  1.06. What is the ratio of the Bank branche(per 100,000 adults) of Sub-Saharan Africa (developing only) in 2007 to that in 2011?
Your answer should be compact. 0.59. What is the ratio of the Bank branche(per 100,000 adults) of Armenia in 2007 to that in 2011?
Make the answer very short. 0.8. What is the ratio of the Bank branche(per 100,000 adults) in Moldova in 2007 to that in 2011?
Your answer should be compact. 0.82. What is the ratio of the Bank branche(per 100,000 adults) in High income in 2007 to that in 2012?
Ensure brevity in your answer.  1.08. What is the ratio of the Bank branche(per 100,000 adults) in Sub-Saharan Africa (developing only) in 2007 to that in 2012?
Your answer should be compact. 0.57. What is the ratio of the Bank branche(per 100,000 adults) of Armenia in 2007 to that in 2012?
Give a very brief answer. 0.75. What is the ratio of the Bank branche(per 100,000 adults) of Moldova in 2007 to that in 2012?
Your answer should be compact. 0.8. What is the ratio of the Bank branche(per 100,000 adults) in High income in 2007 to that in 2013?
Ensure brevity in your answer.  1.1. What is the ratio of the Bank branche(per 100,000 adults) in Sub-Saharan Africa (developing only) in 2007 to that in 2013?
Ensure brevity in your answer.  0.55. What is the ratio of the Bank branche(per 100,000 adults) of Armenia in 2007 to that in 2013?
Offer a terse response. 0.73. What is the ratio of the Bank branche(per 100,000 adults) in Moldova in 2007 to that in 2013?
Your response must be concise. 0.76. What is the ratio of the Bank branche(per 100,000 adults) in High income in 2008 to that in 2009?
Your response must be concise. 1.02. What is the ratio of the Bank branche(per 100,000 adults) of Sub-Saharan Africa (developing only) in 2008 to that in 2009?
Provide a succinct answer. 0.86. What is the ratio of the Bank branche(per 100,000 adults) of Armenia in 2008 to that in 2009?
Provide a short and direct response. 0.97. What is the ratio of the Bank branche(per 100,000 adults) in Moldova in 2008 to that in 2009?
Your answer should be compact. 1.04. What is the ratio of the Bank branche(per 100,000 adults) in High income in 2008 to that in 2010?
Make the answer very short. 1.06. What is the ratio of the Bank branche(per 100,000 adults) of Sub-Saharan Africa (developing only) in 2008 to that in 2010?
Keep it short and to the point. 0.71. What is the ratio of the Bank branche(per 100,000 adults) in Armenia in 2008 to that in 2010?
Offer a terse response. 0.94. What is the ratio of the Bank branche(per 100,000 adults) of Moldova in 2008 to that in 2010?
Your response must be concise. 1.03. What is the ratio of the Bank branche(per 100,000 adults) of High income in 2008 to that in 2011?
Your answer should be very brief. 1.06. What is the ratio of the Bank branche(per 100,000 adults) in Sub-Saharan Africa (developing only) in 2008 to that in 2011?
Ensure brevity in your answer.  0.69. What is the ratio of the Bank branche(per 100,000 adults) of Armenia in 2008 to that in 2011?
Provide a short and direct response. 0.87. What is the ratio of the Bank branche(per 100,000 adults) of Moldova in 2008 to that in 2011?
Make the answer very short. 0.95. What is the ratio of the Bank branche(per 100,000 adults) in High income in 2008 to that in 2012?
Provide a short and direct response. 1.08. What is the ratio of the Bank branche(per 100,000 adults) in Sub-Saharan Africa (developing only) in 2008 to that in 2012?
Make the answer very short. 0.67. What is the ratio of the Bank branche(per 100,000 adults) in Armenia in 2008 to that in 2012?
Provide a succinct answer. 0.82. What is the ratio of the Bank branche(per 100,000 adults) of Moldova in 2008 to that in 2012?
Offer a very short reply. 0.93. What is the ratio of the Bank branche(per 100,000 adults) of High income in 2008 to that in 2013?
Make the answer very short. 1.1. What is the ratio of the Bank branche(per 100,000 adults) of Sub-Saharan Africa (developing only) in 2008 to that in 2013?
Provide a succinct answer. 0.64. What is the ratio of the Bank branche(per 100,000 adults) in Armenia in 2008 to that in 2013?
Provide a succinct answer. 0.8. What is the ratio of the Bank branche(per 100,000 adults) in Moldova in 2008 to that in 2013?
Provide a succinct answer. 0.88. What is the ratio of the Bank branche(per 100,000 adults) of High income in 2009 to that in 2010?
Your response must be concise. 1.03. What is the ratio of the Bank branche(per 100,000 adults) of Sub-Saharan Africa (developing only) in 2009 to that in 2010?
Offer a very short reply. 0.83. What is the ratio of the Bank branche(per 100,000 adults) of Armenia in 2009 to that in 2010?
Give a very brief answer. 0.96. What is the ratio of the Bank branche(per 100,000 adults) in Moldova in 2009 to that in 2010?
Your response must be concise. 0.99. What is the ratio of the Bank branche(per 100,000 adults) of High income in 2009 to that in 2011?
Your response must be concise. 1.03. What is the ratio of the Bank branche(per 100,000 adults) in Sub-Saharan Africa (developing only) in 2009 to that in 2011?
Offer a terse response. 0.8. What is the ratio of the Bank branche(per 100,000 adults) of Armenia in 2009 to that in 2011?
Your response must be concise. 0.89. What is the ratio of the Bank branche(per 100,000 adults) of Moldova in 2009 to that in 2011?
Your answer should be compact. 0.91. What is the ratio of the Bank branche(per 100,000 adults) in High income in 2009 to that in 2012?
Your answer should be very brief. 1.06. What is the ratio of the Bank branche(per 100,000 adults) in Sub-Saharan Africa (developing only) in 2009 to that in 2012?
Offer a terse response. 0.78. What is the ratio of the Bank branche(per 100,000 adults) of Armenia in 2009 to that in 2012?
Ensure brevity in your answer.  0.84. What is the ratio of the Bank branche(per 100,000 adults) of Moldova in 2009 to that in 2012?
Offer a very short reply. 0.89. What is the ratio of the Bank branche(per 100,000 adults) of High income in 2009 to that in 2013?
Your response must be concise. 1.08. What is the ratio of the Bank branche(per 100,000 adults) in Sub-Saharan Africa (developing only) in 2009 to that in 2013?
Your response must be concise. 0.75. What is the ratio of the Bank branche(per 100,000 adults) in Armenia in 2009 to that in 2013?
Keep it short and to the point. 0.82. What is the ratio of the Bank branche(per 100,000 adults) of Moldova in 2009 to that in 2013?
Your answer should be very brief. 0.85. What is the ratio of the Bank branche(per 100,000 adults) in High income in 2010 to that in 2011?
Offer a very short reply. 1. What is the ratio of the Bank branche(per 100,000 adults) in Sub-Saharan Africa (developing only) in 2010 to that in 2011?
Offer a very short reply. 0.97. What is the ratio of the Bank branche(per 100,000 adults) of Armenia in 2010 to that in 2011?
Offer a terse response. 0.93. What is the ratio of the Bank branche(per 100,000 adults) in Moldova in 2010 to that in 2011?
Provide a short and direct response. 0.92. What is the ratio of the Bank branche(per 100,000 adults) in High income in 2010 to that in 2012?
Provide a short and direct response. 1.03. What is the ratio of the Bank branche(per 100,000 adults) of Sub-Saharan Africa (developing only) in 2010 to that in 2012?
Your response must be concise. 0.94. What is the ratio of the Bank branche(per 100,000 adults) in Armenia in 2010 to that in 2012?
Your response must be concise. 0.87. What is the ratio of the Bank branche(per 100,000 adults) in Moldova in 2010 to that in 2012?
Your answer should be compact. 0.9. What is the ratio of the Bank branche(per 100,000 adults) of High income in 2010 to that in 2013?
Make the answer very short. 1.05. What is the ratio of the Bank branche(per 100,000 adults) in Sub-Saharan Africa (developing only) in 2010 to that in 2013?
Your answer should be compact. 0.9. What is the ratio of the Bank branche(per 100,000 adults) in Armenia in 2010 to that in 2013?
Provide a short and direct response. 0.86. What is the ratio of the Bank branche(per 100,000 adults) in Moldova in 2010 to that in 2013?
Keep it short and to the point. 0.86. What is the ratio of the Bank branche(per 100,000 adults) in High income in 2011 to that in 2012?
Offer a terse response. 1.02. What is the ratio of the Bank branche(per 100,000 adults) in Sub-Saharan Africa (developing only) in 2011 to that in 2012?
Provide a short and direct response. 0.97. What is the ratio of the Bank branche(per 100,000 adults) of Armenia in 2011 to that in 2012?
Offer a very short reply. 0.94. What is the ratio of the Bank branche(per 100,000 adults) in Moldova in 2011 to that in 2012?
Give a very brief answer. 0.98. What is the ratio of the Bank branche(per 100,000 adults) of High income in 2011 to that in 2013?
Give a very brief answer. 1.04. What is the ratio of the Bank branche(per 100,000 adults) of Sub-Saharan Africa (developing only) in 2011 to that in 2013?
Your answer should be compact. 0.93. What is the ratio of the Bank branche(per 100,000 adults) in Armenia in 2011 to that in 2013?
Ensure brevity in your answer.  0.92. What is the ratio of the Bank branche(per 100,000 adults) of Moldova in 2011 to that in 2013?
Ensure brevity in your answer.  0.94. What is the ratio of the Bank branche(per 100,000 adults) of High income in 2012 to that in 2013?
Ensure brevity in your answer.  1.02. What is the ratio of the Bank branche(per 100,000 adults) in Sub-Saharan Africa (developing only) in 2012 to that in 2013?
Offer a very short reply. 0.96. What is the ratio of the Bank branche(per 100,000 adults) of Armenia in 2012 to that in 2013?
Keep it short and to the point. 0.98. What is the ratio of the Bank branche(per 100,000 adults) of Moldova in 2012 to that in 2013?
Provide a short and direct response. 0.95. What is the difference between the highest and the second highest Bank branche(per 100,000 adults) in High income?
Ensure brevity in your answer.  0.03. What is the difference between the highest and the second highest Bank branche(per 100,000 adults) in Sub-Saharan Africa (developing only)?
Your answer should be compact. 0.16. What is the difference between the highest and the second highest Bank branche(per 100,000 adults) in Armenia?
Provide a succinct answer. 0.43. What is the difference between the highest and the second highest Bank branche(per 100,000 adults) in Moldova?
Make the answer very short. 0.58. What is the difference between the highest and the lowest Bank branche(per 100,000 adults) in High income?
Give a very brief answer. 2.37. What is the difference between the highest and the lowest Bank branche(per 100,000 adults) of Sub-Saharan Africa (developing only)?
Give a very brief answer. 1.73. What is the difference between the highest and the lowest Bank branche(per 100,000 adults) of Armenia?
Offer a very short reply. 5.68. What is the difference between the highest and the lowest Bank branche(per 100,000 adults) of Moldova?
Provide a short and direct response. 2.86. 